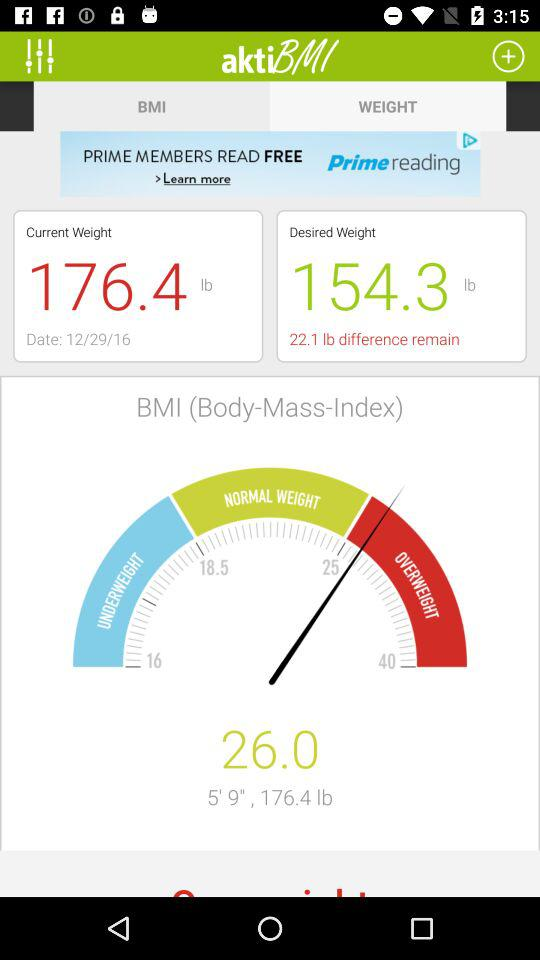What is my current BMI?
Answer the question using a single word or phrase. 26.0 